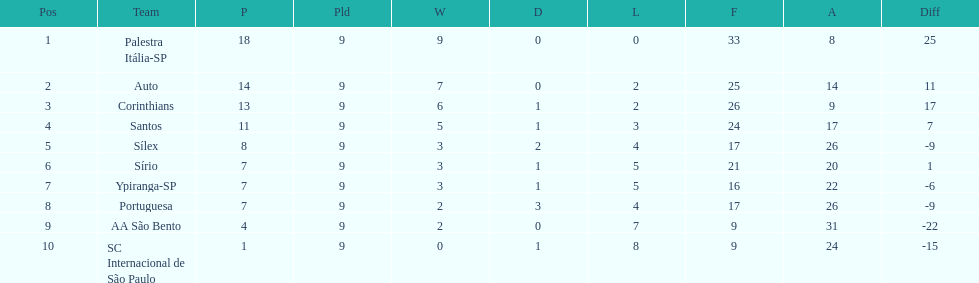In the 1926 brazilian football season, how many squads accumulated over 10 points? 4. 